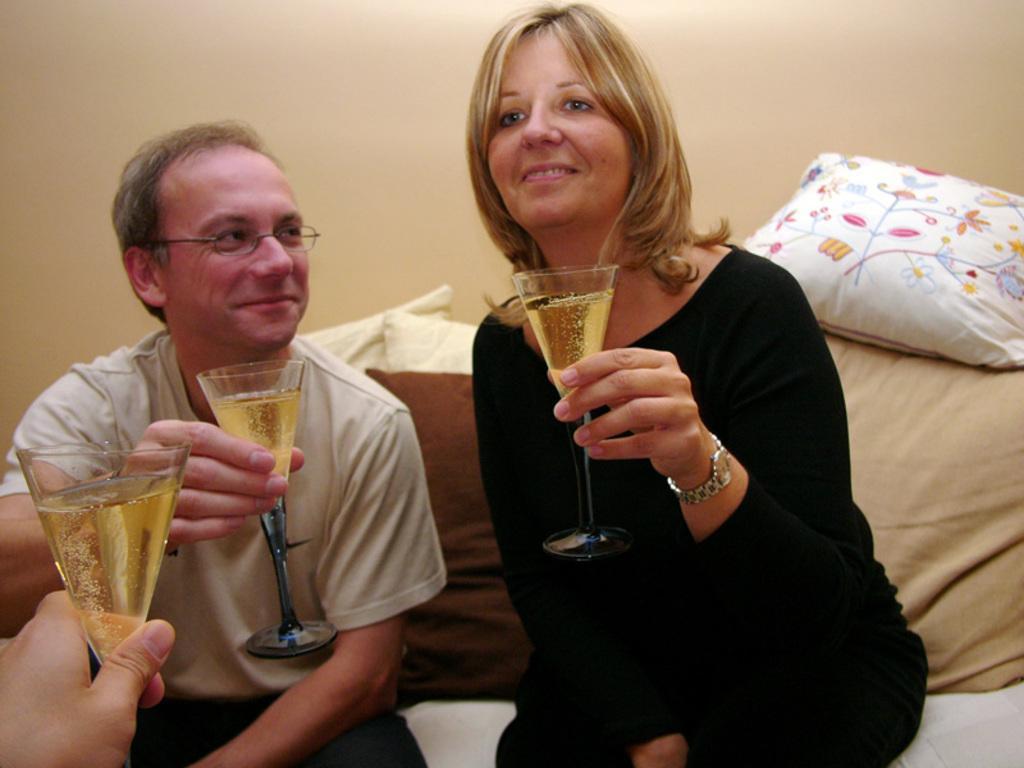Describe this image in one or two sentences. In this picture we can see a man and a woman holding a glass with their hands. He is smiling and he has spectacles. These are the pillows and there is a wall. 